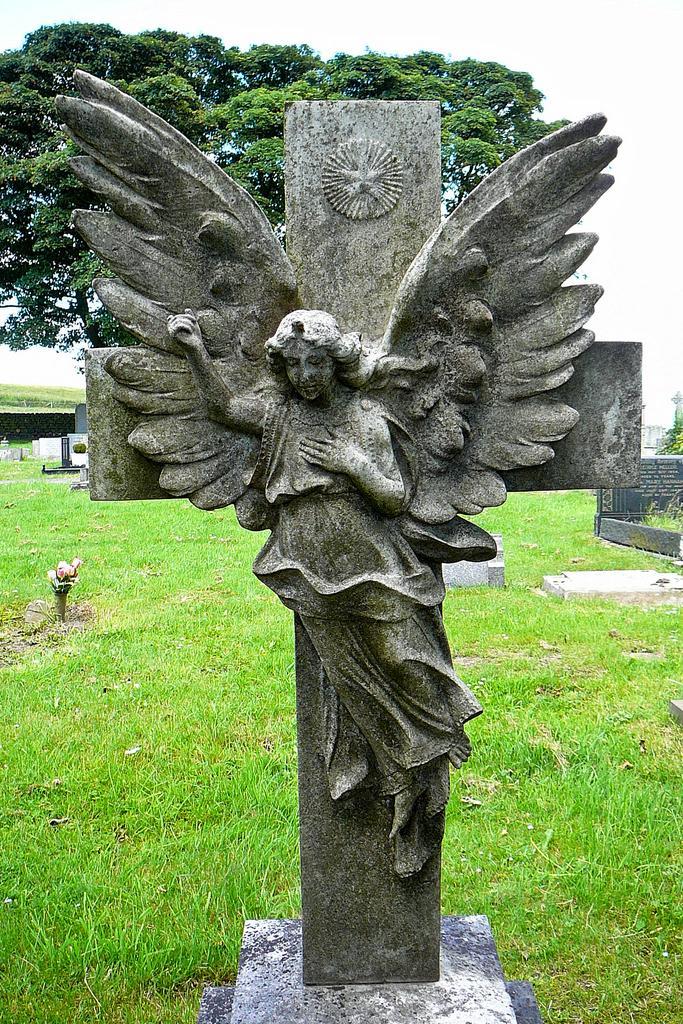Can you describe this image briefly? In this picture, we can see a statue on the stone and behind the statue there is a trees, wall, grass and a sky. 